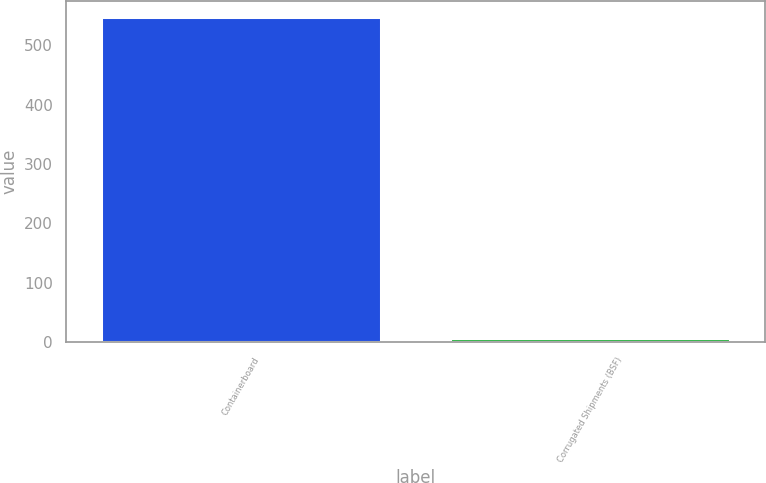Convert chart to OTSL. <chart><loc_0><loc_0><loc_500><loc_500><bar_chart><fcel>Containerboard<fcel>Corrugated Shipments (BSF)<nl><fcel>548<fcel>7.2<nl></chart> 